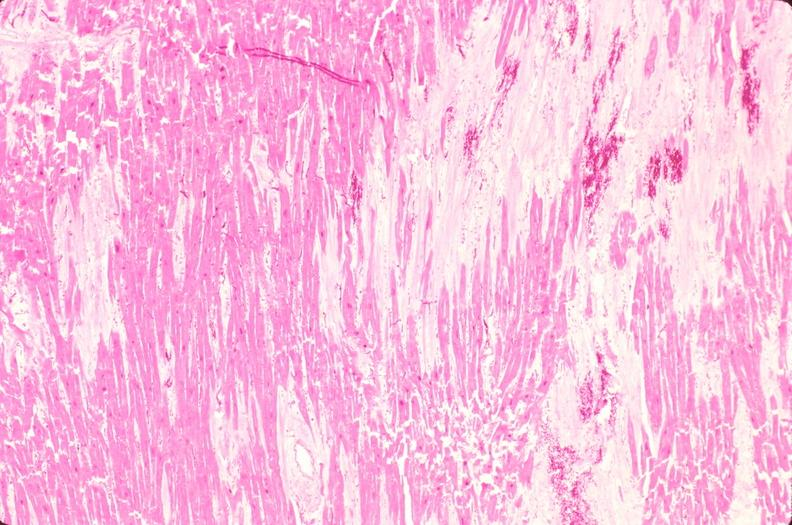s cardiovascular present?
Answer the question using a single word or phrase. Yes 